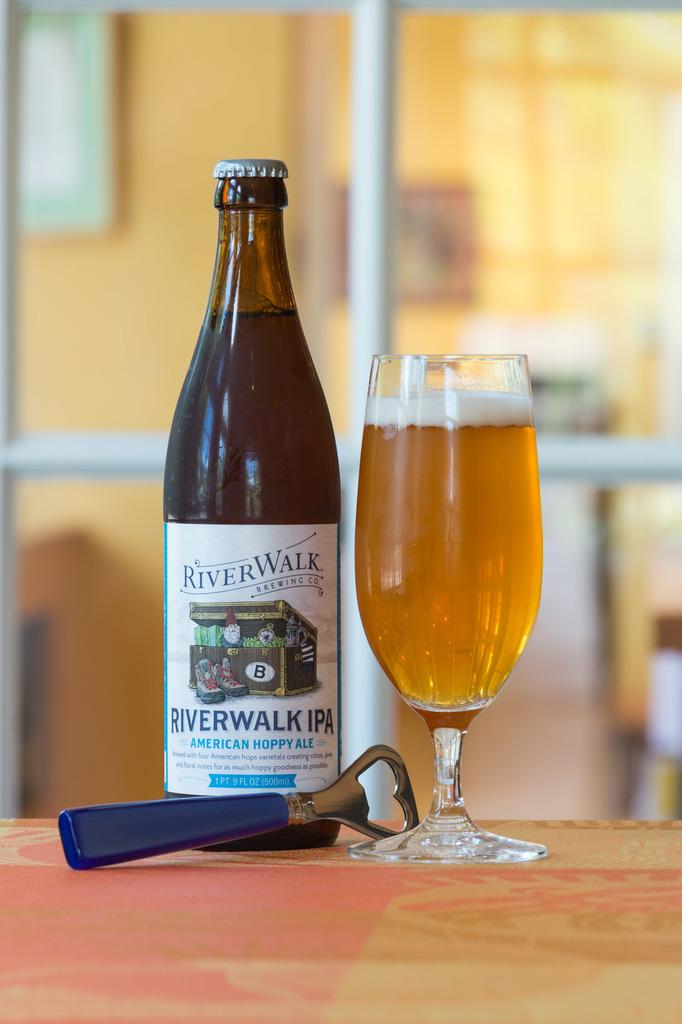Wha type of beer is river walk?
Make the answer very short. American hoppy ale. 